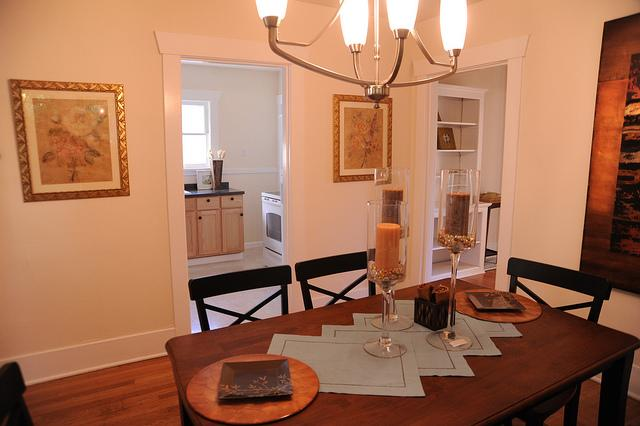What is inside the tall glasses?

Choices:
A) candles
B) beer
C) wine
D) candy candles 